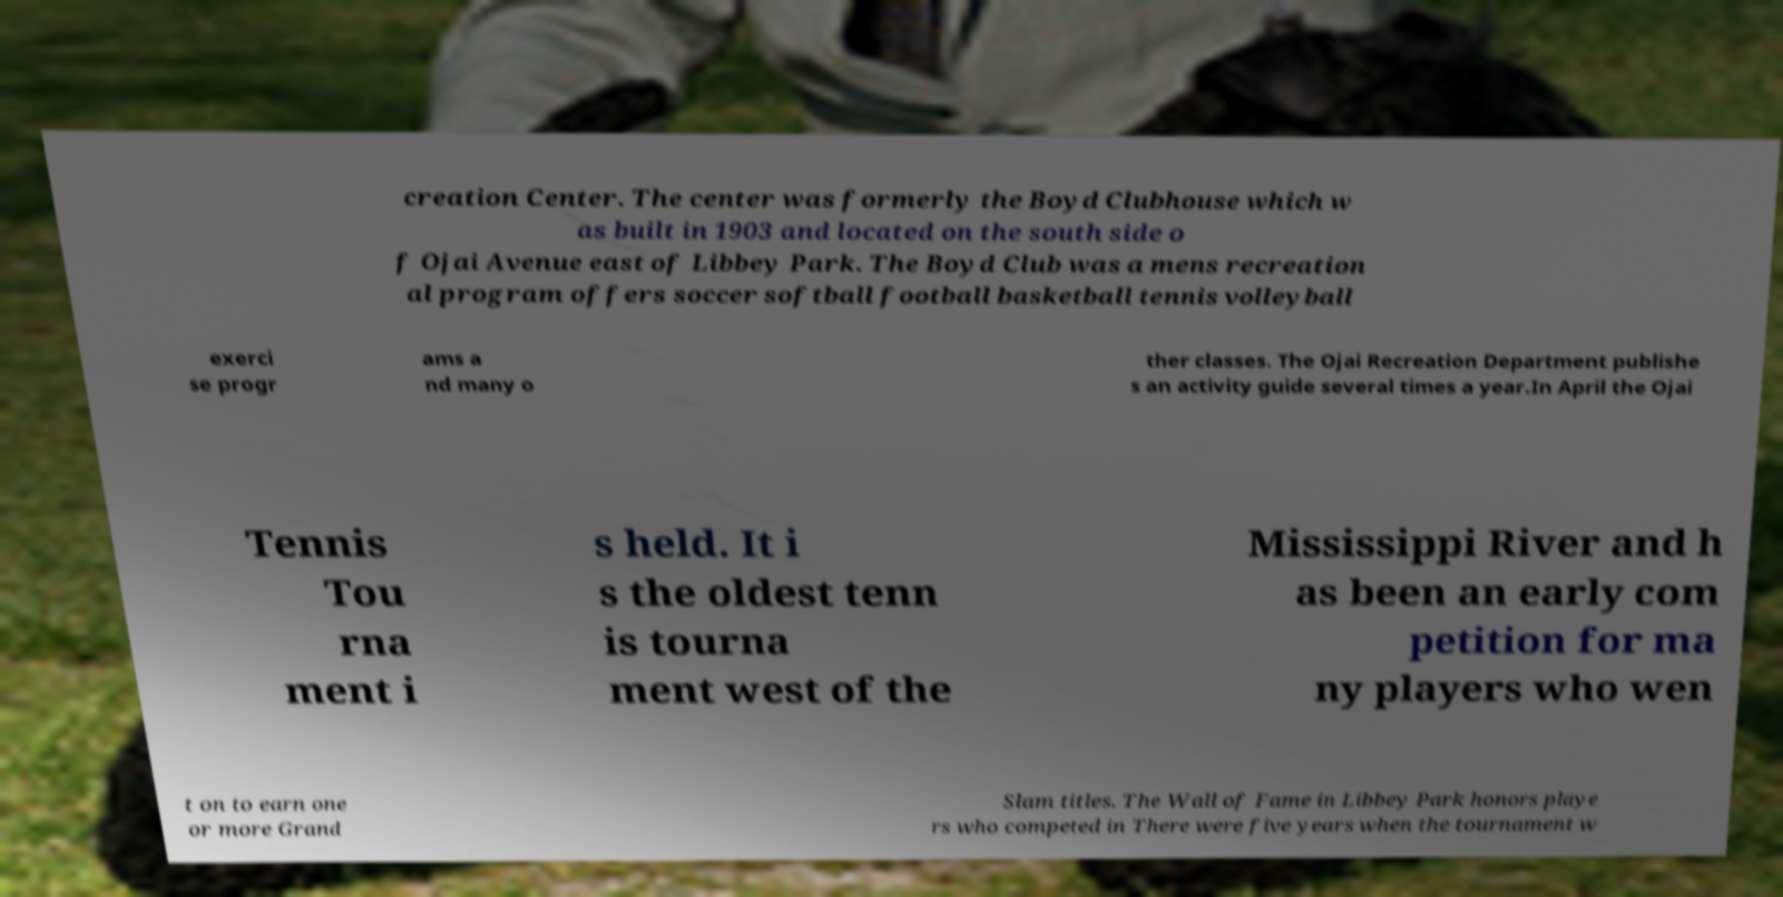Please identify and transcribe the text found in this image. creation Center. The center was formerly the Boyd Clubhouse which w as built in 1903 and located on the south side o f Ojai Avenue east of Libbey Park. The Boyd Club was a mens recreation al program offers soccer softball football basketball tennis volleyball exerci se progr ams a nd many o ther classes. The Ojai Recreation Department publishe s an activity guide several times a year.In April the Ojai Tennis Tou rna ment i s held. It i s the oldest tenn is tourna ment west of the Mississippi River and h as been an early com petition for ma ny players who wen t on to earn one or more Grand Slam titles. The Wall of Fame in Libbey Park honors playe rs who competed in There were five years when the tournament w 